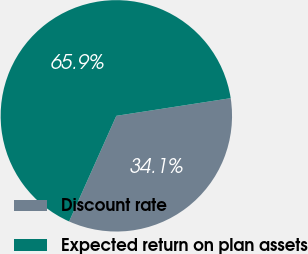Convert chart. <chart><loc_0><loc_0><loc_500><loc_500><pie_chart><fcel>Discount rate<fcel>Expected return on plan assets<nl><fcel>34.13%<fcel>65.87%<nl></chart> 